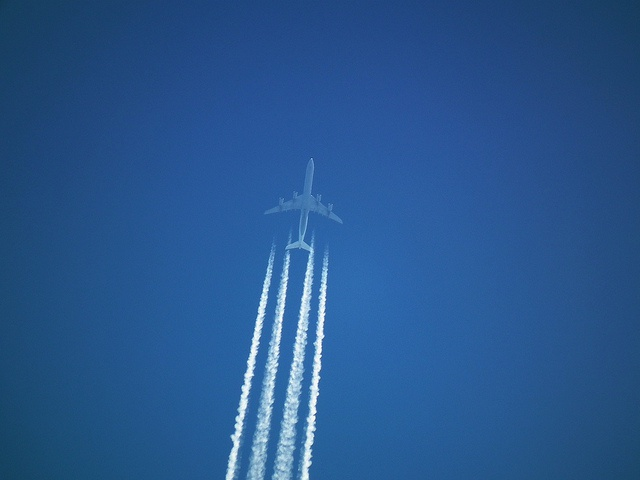Describe the objects in this image and their specific colors. I can see a airplane in darkblue, gray, and darkgray tones in this image. 